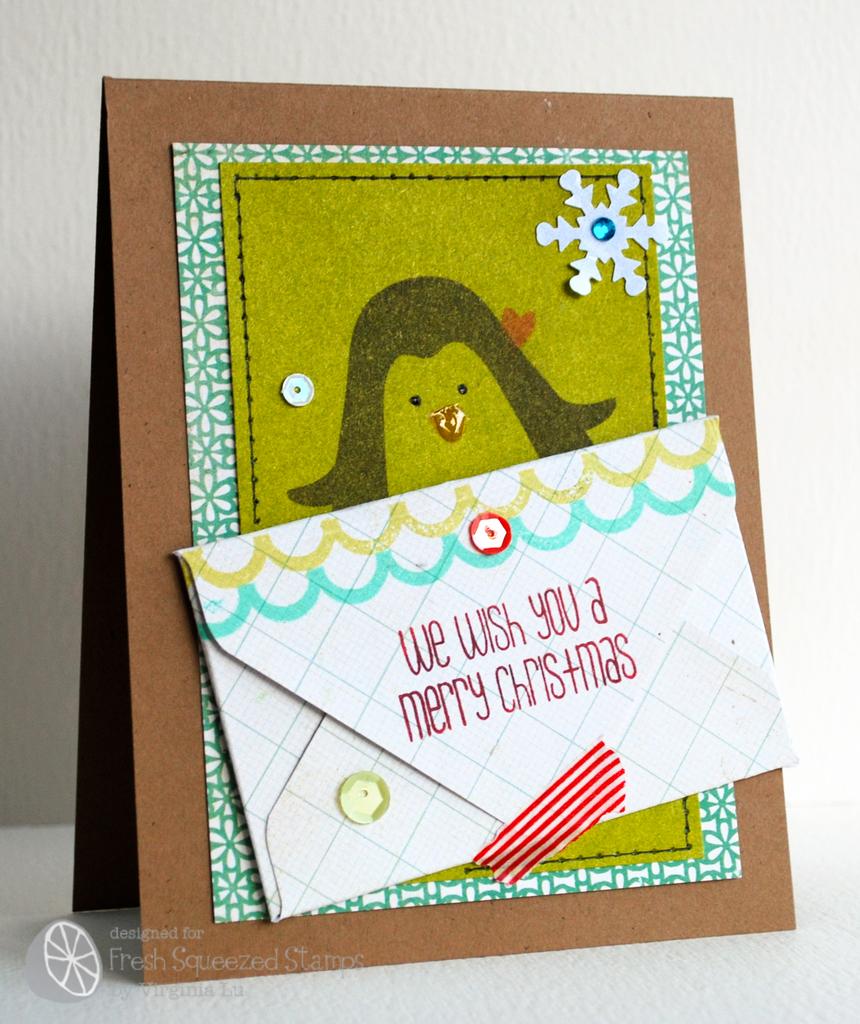What holiday does the card have?
Provide a short and direct response. Christmas. What are they wishing you?
Offer a very short reply. Merry christmas. 